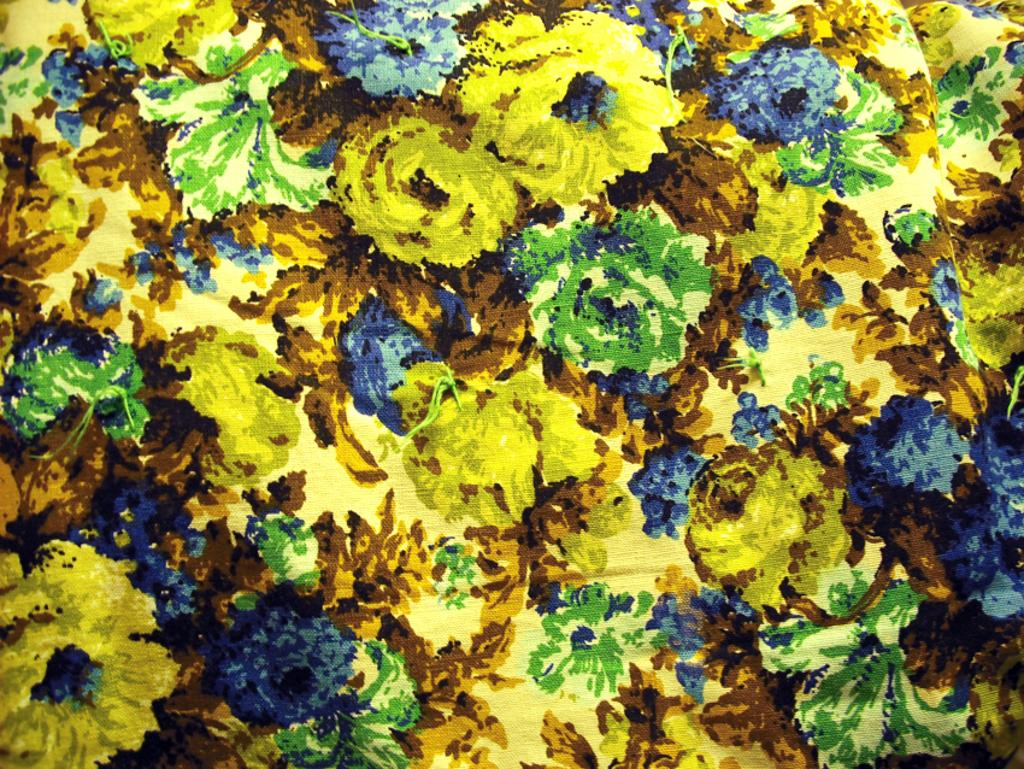What colors are used in the painting in the image? The painting is in yellow, blue, and green colors. Can you see a guitar being played in the painting? There is no guitar or any musical instrument visible in the painting; it only features yellow, blue, and green colors. 